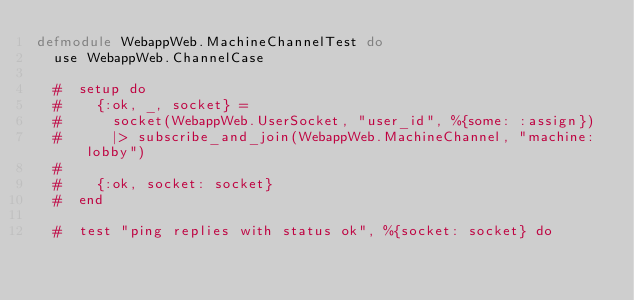Convert code to text. <code><loc_0><loc_0><loc_500><loc_500><_Elixir_>defmodule WebappWeb.MachineChannelTest do
  use WebappWeb.ChannelCase

  #  setup do
  #    {:ok, _, socket} =
  #      socket(WebappWeb.UserSocket, "user_id", %{some: :assign})
  #      |> subscribe_and_join(WebappWeb.MachineChannel, "machine:lobby")
  #
  #    {:ok, socket: socket}
  #  end

  #  test "ping replies with status ok", %{socket: socket} do</code> 